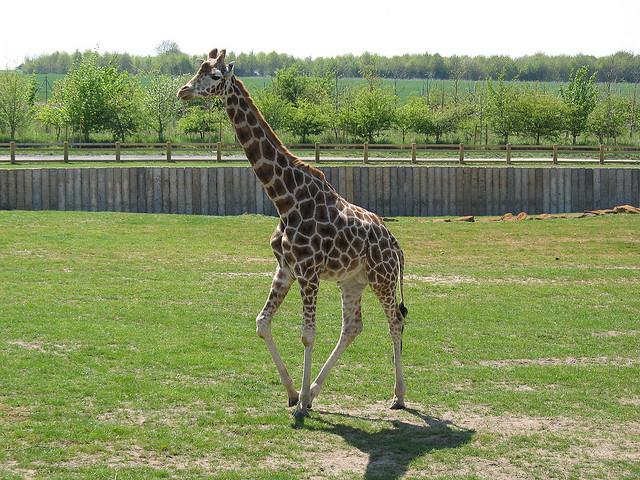How many giraffes are there?
Give a very brief answer. 1. What type of animal is pictured?
Short answer required. Giraffe. What is the giraffe doing?
Be succinct. Walking. Is this animal shown in its natural habitat?
Answer briefly. No. 